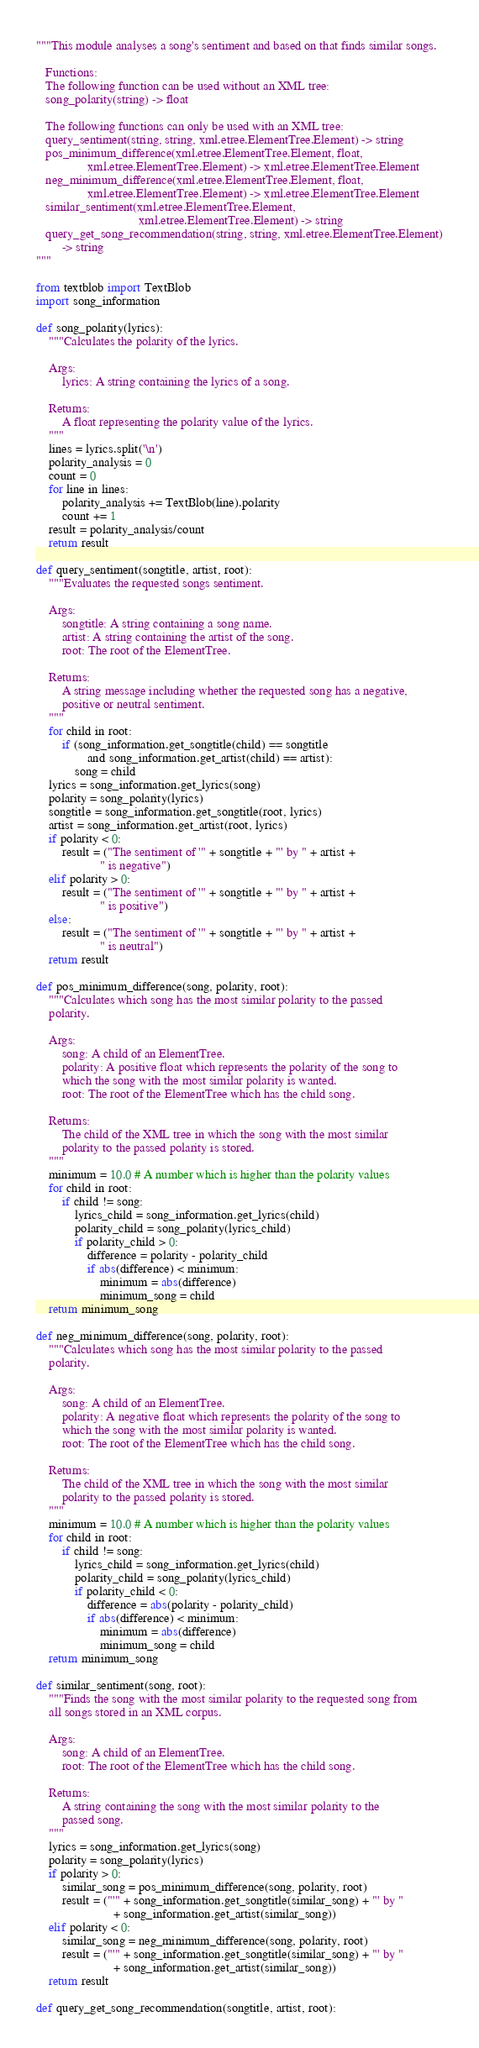<code> <loc_0><loc_0><loc_500><loc_500><_Python_>"""This module analyses a song's sentiment and based on that finds similar songs.

   Functions:
   The following function can be used without an XML tree:
   song_polarity(string) -> float

   The following functions can only be used with an XML tree:
   query_sentiment(string, string, xml.etree.ElementTree.Element) -> string
   pos_minimum_difference(xml.etree.ElementTree.Element, float,
                xml.etree.ElementTree.Element) -> xml.etree.ElementTree.Element
   neg_minimum_difference(xml.etree.ElementTree.Element, float,
                xml.etree.ElementTree.Element) -> xml.etree.ElementTree.Element
   similar_sentiment(xml.etree.ElementTree.Element,
                                xml.etree.ElementTree.Element) -> string
   query_get_song_recommendation(string, string, xml.etree.ElementTree.Element)
        -> string
"""

from textblob import TextBlob
import song_information

def song_polarity(lyrics):
    """Calculates the polarity of the lyrics.

    Args:
        lyrics: A string containing the lyrics of a song.

    Returns:
        A float representing the polarity value of the lyrics.
    """
    lines = lyrics.split('\n')
    polarity_analysis = 0
    count = 0
    for line in lines:
        polarity_analysis += TextBlob(line).polarity
        count += 1
    result = polarity_analysis/count
    return result

def query_sentiment(songtitle, artist, root):
    """Evaluates the requested songs sentiment.

    Args:
        songtitle: A string containing a song name.
        artist: A string containing the artist of the song.
        root: The root of the ElementTree.

    Returns:
        A string message including whether the requested song has a negative,
        positive or neutral sentiment.
    """
    for child in root:
        if (song_information.get_songtitle(child) == songtitle
                and song_information.get_artist(child) == artist):
            song = child
    lyrics = song_information.get_lyrics(song)
    polarity = song_polarity(lyrics)
    songtitle = song_information.get_songtitle(root, lyrics)
    artist = song_information.get_artist(root, lyrics)
    if polarity < 0:
        result = ("The sentiment of '" + songtitle + "' by " + artist +
                    " is negative")
    elif polarity > 0:
        result = ("The sentiment of '" + songtitle + "' by " + artist +
                    " is positive")
    else:
        result = ("The sentiment of '" + songtitle + "' by " + artist +
                    " is neutral")
    return result

def pos_minimum_difference(song, polarity, root):
    """Calculates which song has the most similar polarity to the passed
    polarity.

    Args:
        song: A child of an ElementTree.
        polarity: A positive float which represents the polarity of the song to
        which the song with the most similar polarity is wanted.
        root: The root of the ElementTree which has the child song.

    Returns:
        The child of the XML tree in which the song with the most similar
        polarity to the passed polarity is stored.
    """
    minimum = 10.0 # A number which is higher than the polarity values
    for child in root:
        if child != song:
            lyrics_child = song_information.get_lyrics(child)
            polarity_child = song_polarity(lyrics_child)
            if polarity_child > 0:
                difference = polarity - polarity_child
                if abs(difference) < minimum:
                    minimum = abs(difference)
                    minimum_song = child
    return minimum_song

def neg_minimum_difference(song, polarity, root):
    """Calculates which song has the most similar polarity to the passed
    polarity.

    Args:
        song: A child of an ElementTree.
        polarity: A negative float which represents the polarity of the song to
        which the song with the most similar polarity is wanted.
        root: The root of the ElementTree which has the child song.

    Returns:
        The child of the XML tree in which the song with the most similar
        polarity to the passed polarity is stored.
    """
    minimum = 10.0 # A number which is higher than the polarity values
    for child in root:
        if child != song:
            lyrics_child = song_information.get_lyrics(child)
            polarity_child = song_polarity(lyrics_child)
            if polarity_child < 0:
                difference = abs(polarity - polarity_child)
                if abs(difference) < minimum:
                    minimum = abs(difference)
                    minimum_song = child
    return minimum_song

def similar_sentiment(song, root):
    """Finds the song with the most similar polarity to the requested song from
    all songs stored in an XML corpus.

    Args:
        song: A child of an ElementTree.
        root: The root of the ElementTree which has the child song.

    Returns:
        A string containing the song with the most similar polarity to the
        passed song.
    """
    lyrics = song_information.get_lyrics(song)
    polarity = song_polarity(lyrics)
    if polarity > 0:
        similar_song = pos_minimum_difference(song, polarity, root)
        result = ("'" + song_information.get_songtitle(similar_song) + "' by "
                        + song_information.get_artist(similar_song))
    elif polarity < 0:
        similar_song = neg_minimum_difference(song, polarity, root)
        result = ("'" + song_information.get_songtitle(similar_song) + "' by "
                        + song_information.get_artist(similar_song))
    return result

def query_get_song_recommendation(songtitle, artist, root):</code> 